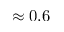Convert formula to latex. <formula><loc_0><loc_0><loc_500><loc_500>\approx 0 . 6</formula> 